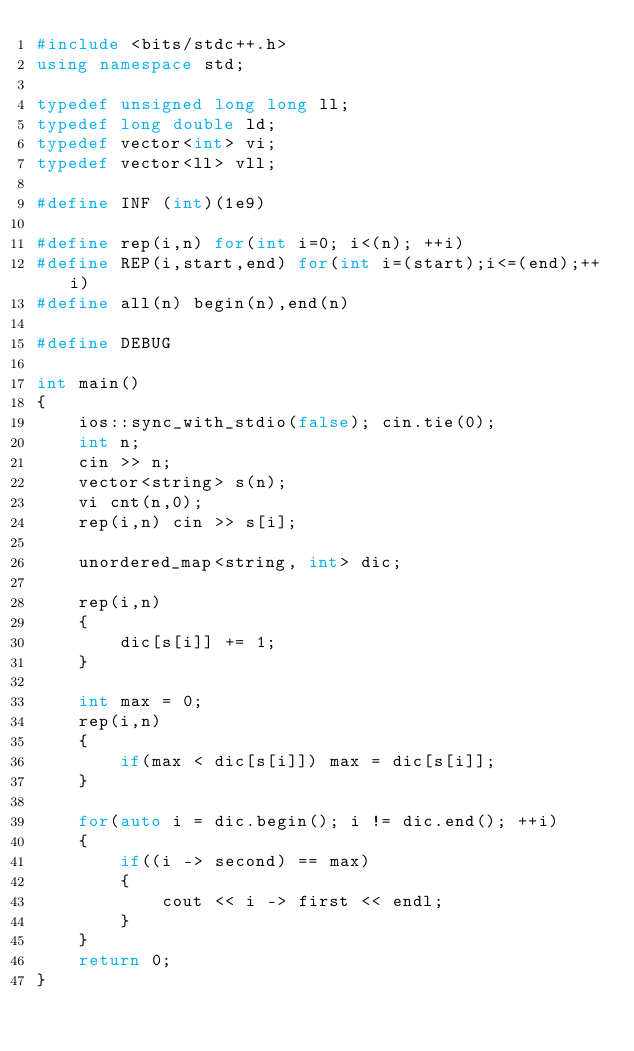Convert code to text. <code><loc_0><loc_0><loc_500><loc_500><_C++_>#include <bits/stdc++.h>
using namespace std;

typedef unsigned long long ll;
typedef long double ld;
typedef vector<int> vi;
typedef vector<ll> vll;

#define INF (int)(1e9)

#define rep(i,n) for(int i=0; i<(n); ++i)
#define REP(i,start,end) for(int i=(start);i<=(end);++i)
#define all(n) begin(n),end(n)

#define DEBUG

int main()
{
	ios::sync_with_stdio(false); cin.tie(0);
	int n;
	cin >> n;
	vector<string> s(n);
	vi cnt(n,0);
	rep(i,n) cin >> s[i];

	unordered_map<string, int> dic;

	rep(i,n)
	{
		dic[s[i]] += 1;
	}

	int max = 0;
	rep(i,n)
	{
		if(max < dic[s[i]]) max = dic[s[i]];
	}

	for(auto i = dic.begin(); i != dic.end(); ++i)
	{
		if((i -> second) == max)
		{
			cout << i -> first << endl;
		}
	}
	return 0;
}</code> 